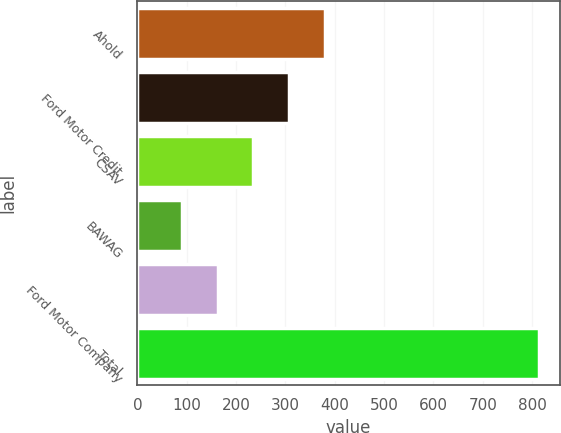<chart> <loc_0><loc_0><loc_500><loc_500><bar_chart><fcel>Ahold<fcel>Ford Motor Credit<fcel>CSAV<fcel>BAWAG<fcel>Ford Motor Company<fcel>Total<nl><fcel>380<fcel>307.5<fcel>235<fcel>90<fcel>162.5<fcel>815<nl></chart> 